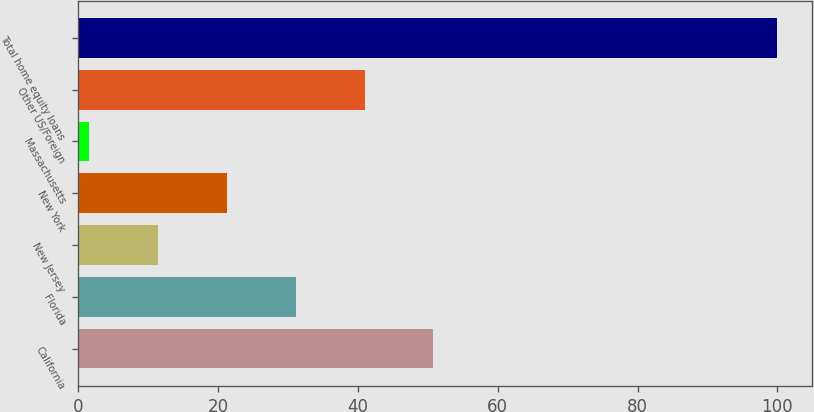Convert chart. <chart><loc_0><loc_0><loc_500><loc_500><bar_chart><fcel>California<fcel>Florida<fcel>New Jersey<fcel>New York<fcel>Massachusetts<fcel>Other US/Foreign<fcel>Total home equity loans<nl><fcel>50.8<fcel>31.12<fcel>11.44<fcel>21.28<fcel>1.6<fcel>40.96<fcel>100<nl></chart> 